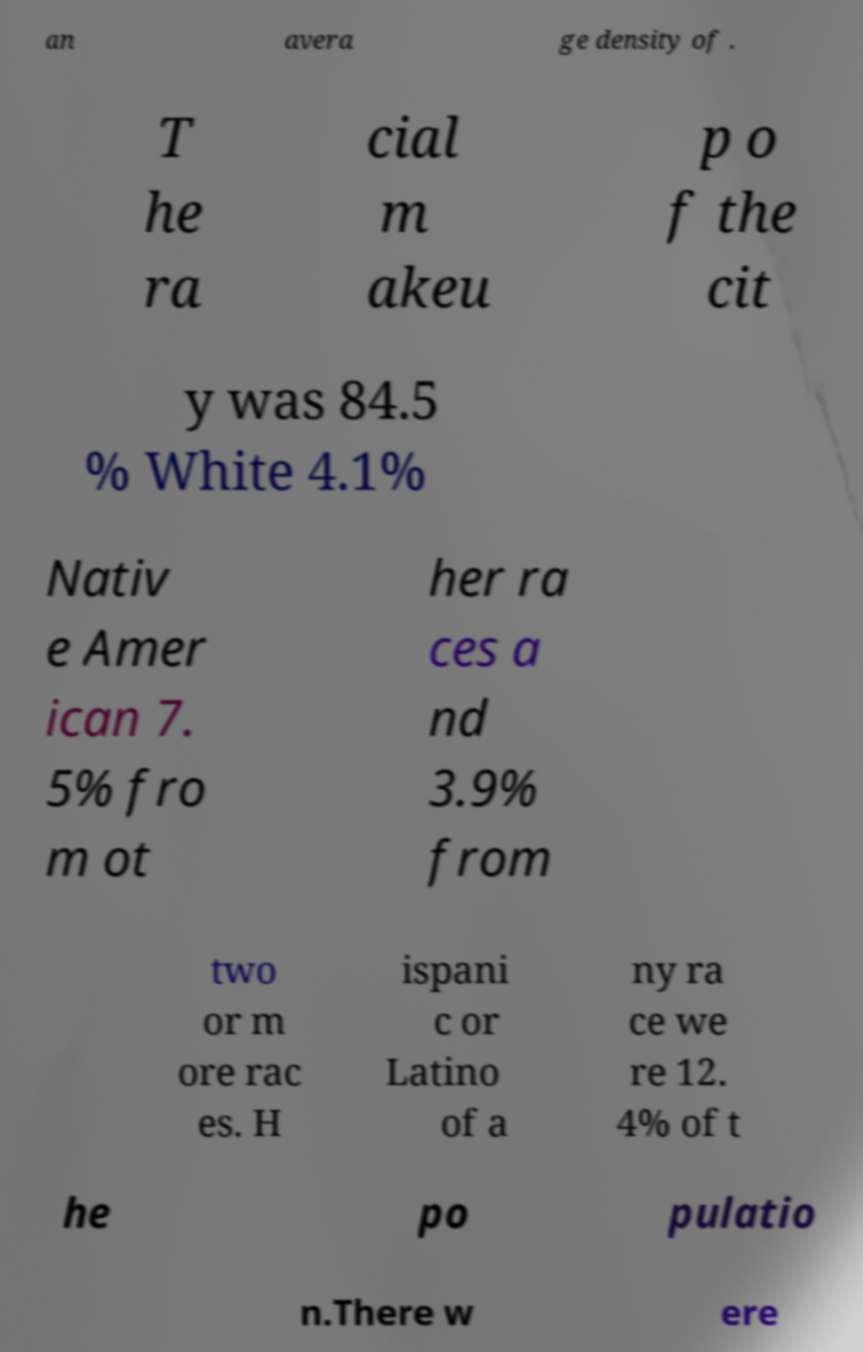There's text embedded in this image that I need extracted. Can you transcribe it verbatim? an avera ge density of . T he ra cial m akeu p o f the cit y was 84.5 % White 4.1% Nativ e Amer ican 7. 5% fro m ot her ra ces a nd 3.9% from two or m ore rac es. H ispani c or Latino of a ny ra ce we re 12. 4% of t he po pulatio n.There w ere 